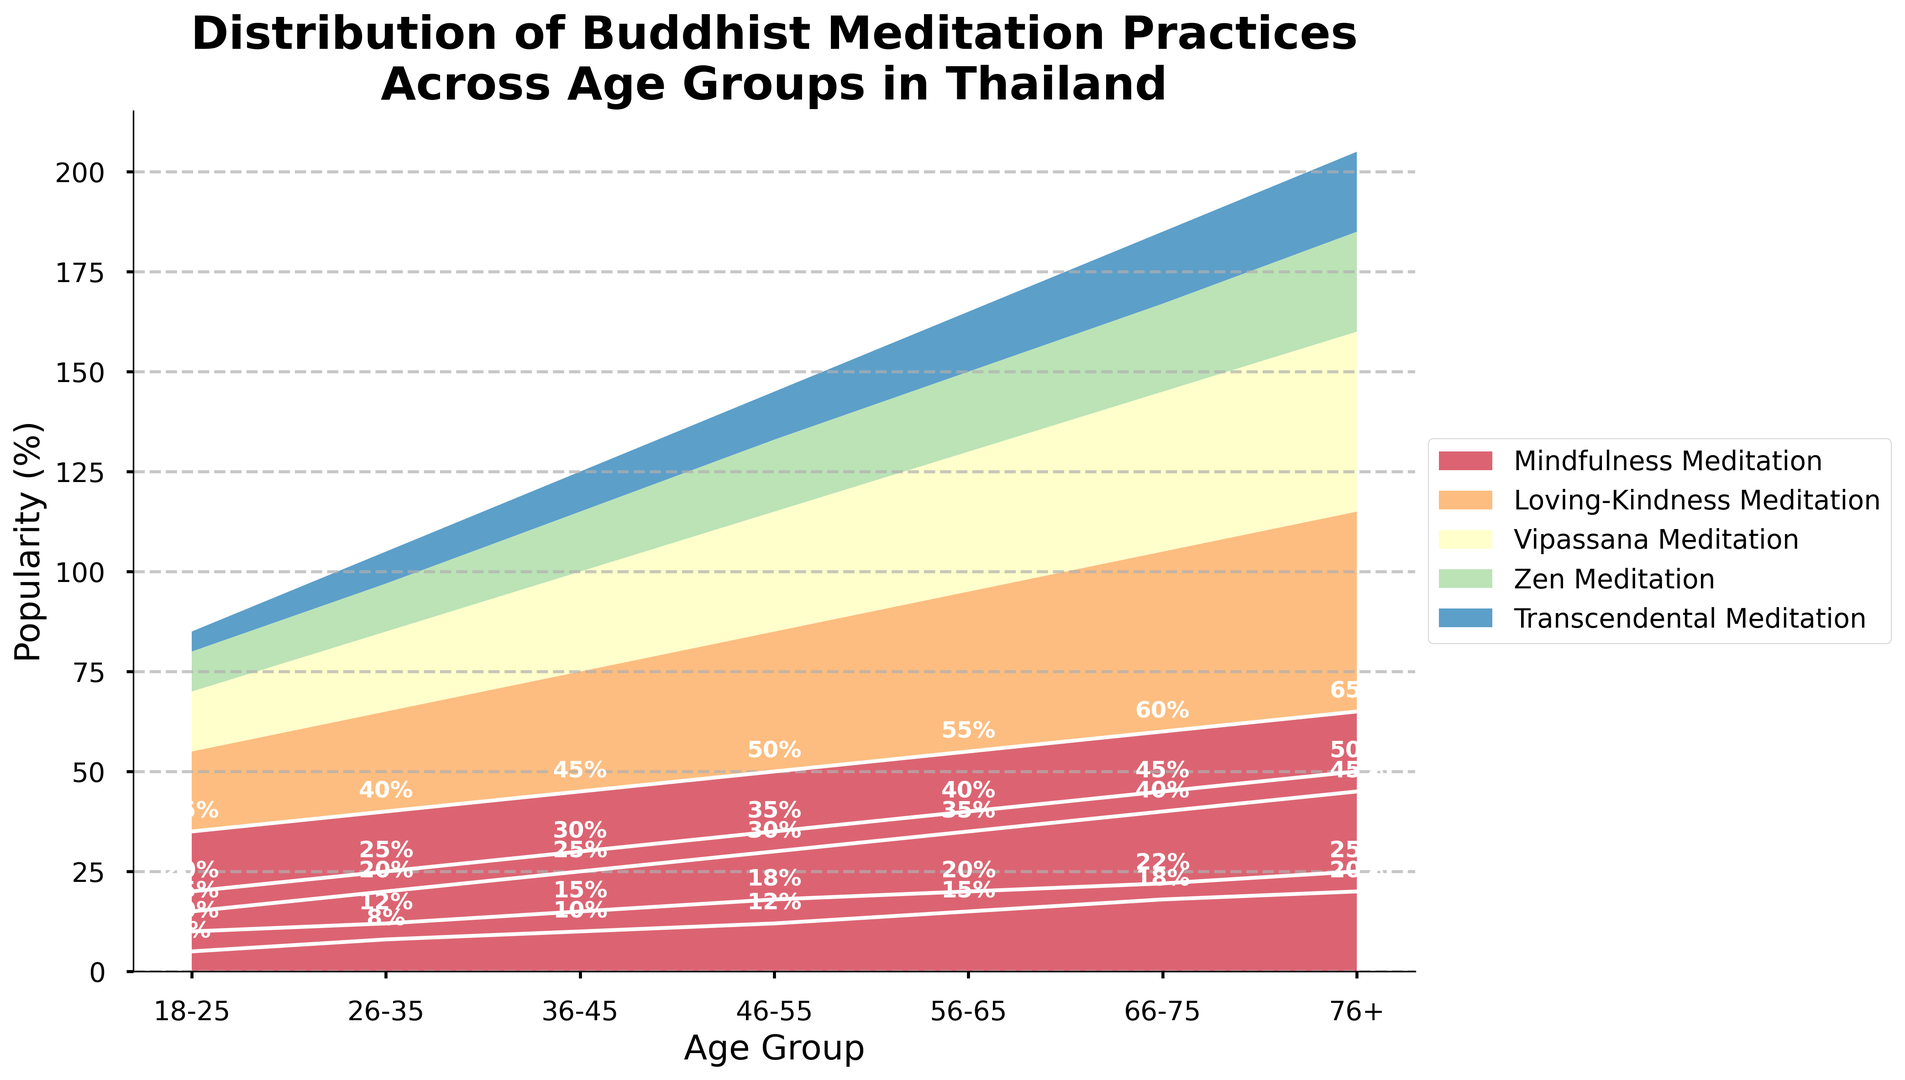What age group has the highest popularity for Vipassana Meditation? By observing the highest point of the light green area representing Vipassana Meditation across the age groups, it peaks at the 76+ age group.
Answer: 76+ Which age group has the greatest difference in popularity between Mindfulness Meditation and Transcendental Meditation? To determine the greatest difference, compare the difference (subtraction) between the heights of the red and purple areas in each age group. The 76+ age group shows the largest gap between these two practices, with Mindfulness Meditation at 65% and Transcendental Meditation at 20%, resulting in a difference of 45%.
Answer: 76+ How does the popularity of Zen Meditation change from age group 18-25 to 66-75? Observe the yellow area representing Zen Meditation from the first to the sixth age groups: it increases constantly. Specifically, 10% at 18-25, 12% at 26-35, 15% at 36-45, 18% at 46-55, 20% at 56-65, and 22% at 66-75.
Answer: Increases What is the total popularity of Mindfulness Meditation for all age groups combined? Sum the popularity percentages of the Mindfulness Meditation (red area) across all age groups: 35 + 40 + 45 + 50 + 55 + 60 + 65 = 350%.
Answer: 350% Which meditation practice is the least popular among the 56-65 age group? Look at the heights of the colored areas in the 56-65 age group column. The purple area representing Transcendental Meditation is the smallest at 15%.
Answer: Transcendental Meditation In which age group does Loving-Kindness Meditation surpass Vipassana Meditation by the largest margin? Compare the difference between the heights of the blue area (Loving-Kindness Meditation) and the light green area (Vipassana Meditation) for each age group. The 66-75 age group shows the largest margin, with Loving-Kindness Meditation at 45% and Vipassana Meditation at 40%, resulting in a 5% difference.
Answer: 66-75 What trend can be observed in the popularity of Transcendental Meditation across age groups? Visually, the purple area representing Transcendental Meditation increases slightly and consistently from one age group to the next: 5% at 18-25, 8% at 26-35, 10% at 36-45, 12% at 46-55, 15% at 56-65, 18% at 66-75, and 20% at 76+.
Answer: Increasing trend 